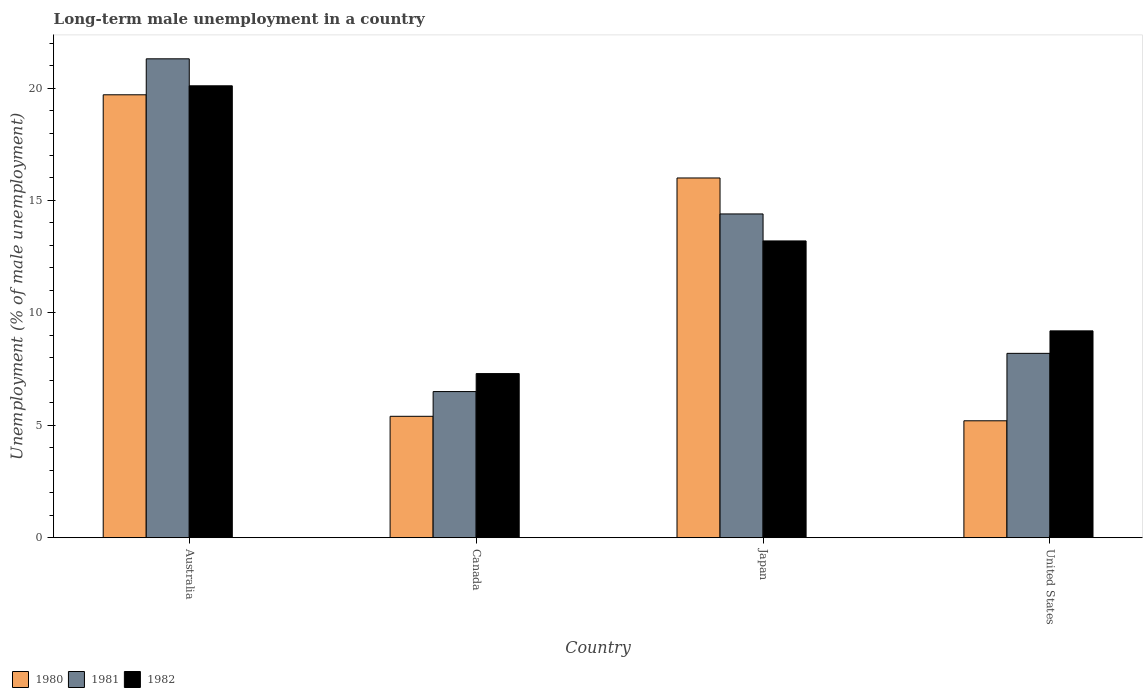How many different coloured bars are there?
Your response must be concise. 3. Are the number of bars per tick equal to the number of legend labels?
Provide a succinct answer. Yes. How many bars are there on the 4th tick from the right?
Your answer should be very brief. 3. What is the label of the 2nd group of bars from the left?
Give a very brief answer. Canada. In how many cases, is the number of bars for a given country not equal to the number of legend labels?
Your answer should be very brief. 0. What is the percentage of long-term unemployed male population in 1982 in United States?
Make the answer very short. 9.2. Across all countries, what is the maximum percentage of long-term unemployed male population in 1980?
Your answer should be very brief. 19.7. Across all countries, what is the minimum percentage of long-term unemployed male population in 1982?
Ensure brevity in your answer.  7.3. What is the total percentage of long-term unemployed male population in 1982 in the graph?
Your answer should be compact. 49.8. What is the difference between the percentage of long-term unemployed male population in 1980 in Canada and that in Japan?
Your answer should be very brief. -10.6. What is the difference between the percentage of long-term unemployed male population in 1982 in United States and the percentage of long-term unemployed male population in 1981 in Japan?
Your answer should be compact. -5.2. What is the average percentage of long-term unemployed male population in 1980 per country?
Provide a short and direct response. 11.58. What is the difference between the percentage of long-term unemployed male population of/in 1981 and percentage of long-term unemployed male population of/in 1980 in Japan?
Offer a very short reply. -1.6. What is the ratio of the percentage of long-term unemployed male population in 1980 in Australia to that in Canada?
Ensure brevity in your answer.  3.65. Is the percentage of long-term unemployed male population in 1982 in Japan less than that in United States?
Offer a terse response. No. Is the difference between the percentage of long-term unemployed male population in 1981 in Australia and Canada greater than the difference between the percentage of long-term unemployed male population in 1980 in Australia and Canada?
Offer a terse response. Yes. What is the difference between the highest and the second highest percentage of long-term unemployed male population in 1982?
Your response must be concise. -10.9. What is the difference between the highest and the lowest percentage of long-term unemployed male population in 1980?
Ensure brevity in your answer.  14.5. In how many countries, is the percentage of long-term unemployed male population in 1980 greater than the average percentage of long-term unemployed male population in 1980 taken over all countries?
Make the answer very short. 2. How many bars are there?
Provide a succinct answer. 12. Are all the bars in the graph horizontal?
Your answer should be very brief. No. Are the values on the major ticks of Y-axis written in scientific E-notation?
Offer a terse response. No. Does the graph contain any zero values?
Your answer should be very brief. No. Where does the legend appear in the graph?
Offer a terse response. Bottom left. What is the title of the graph?
Make the answer very short. Long-term male unemployment in a country. What is the label or title of the X-axis?
Provide a succinct answer. Country. What is the label or title of the Y-axis?
Keep it short and to the point. Unemployment (% of male unemployment). What is the Unemployment (% of male unemployment) of 1980 in Australia?
Keep it short and to the point. 19.7. What is the Unemployment (% of male unemployment) in 1981 in Australia?
Your answer should be very brief. 21.3. What is the Unemployment (% of male unemployment) in 1982 in Australia?
Provide a succinct answer. 20.1. What is the Unemployment (% of male unemployment) of 1980 in Canada?
Ensure brevity in your answer.  5.4. What is the Unemployment (% of male unemployment) in 1981 in Canada?
Provide a succinct answer. 6.5. What is the Unemployment (% of male unemployment) of 1982 in Canada?
Your answer should be very brief. 7.3. What is the Unemployment (% of male unemployment) in 1980 in Japan?
Give a very brief answer. 16. What is the Unemployment (% of male unemployment) in 1981 in Japan?
Provide a succinct answer. 14.4. What is the Unemployment (% of male unemployment) in 1982 in Japan?
Give a very brief answer. 13.2. What is the Unemployment (% of male unemployment) of 1980 in United States?
Make the answer very short. 5.2. What is the Unemployment (% of male unemployment) in 1981 in United States?
Make the answer very short. 8.2. What is the Unemployment (% of male unemployment) in 1982 in United States?
Offer a very short reply. 9.2. Across all countries, what is the maximum Unemployment (% of male unemployment) in 1980?
Ensure brevity in your answer.  19.7. Across all countries, what is the maximum Unemployment (% of male unemployment) in 1981?
Your answer should be compact. 21.3. Across all countries, what is the maximum Unemployment (% of male unemployment) in 1982?
Your response must be concise. 20.1. Across all countries, what is the minimum Unemployment (% of male unemployment) in 1980?
Your answer should be very brief. 5.2. Across all countries, what is the minimum Unemployment (% of male unemployment) of 1982?
Provide a succinct answer. 7.3. What is the total Unemployment (% of male unemployment) of 1980 in the graph?
Offer a terse response. 46.3. What is the total Unemployment (% of male unemployment) in 1981 in the graph?
Ensure brevity in your answer.  50.4. What is the total Unemployment (% of male unemployment) of 1982 in the graph?
Your answer should be compact. 49.8. What is the difference between the Unemployment (% of male unemployment) in 1980 in Australia and that in Canada?
Your response must be concise. 14.3. What is the difference between the Unemployment (% of male unemployment) of 1982 in Australia and that in Canada?
Make the answer very short. 12.8. What is the difference between the Unemployment (% of male unemployment) in 1980 in Australia and that in Japan?
Offer a very short reply. 3.7. What is the difference between the Unemployment (% of male unemployment) in 1980 in Canada and that in Japan?
Make the answer very short. -10.6. What is the difference between the Unemployment (% of male unemployment) of 1981 in Canada and that in Japan?
Provide a succinct answer. -7.9. What is the difference between the Unemployment (% of male unemployment) of 1980 in Canada and that in United States?
Provide a succinct answer. 0.2. What is the difference between the Unemployment (% of male unemployment) in 1980 in Japan and that in United States?
Offer a terse response. 10.8. What is the difference between the Unemployment (% of male unemployment) in 1982 in Japan and that in United States?
Give a very brief answer. 4. What is the difference between the Unemployment (% of male unemployment) in 1980 in Australia and the Unemployment (% of male unemployment) in 1981 in Canada?
Give a very brief answer. 13.2. What is the difference between the Unemployment (% of male unemployment) in 1980 in Australia and the Unemployment (% of male unemployment) in 1981 in Japan?
Offer a very short reply. 5.3. What is the difference between the Unemployment (% of male unemployment) of 1980 in Australia and the Unemployment (% of male unemployment) of 1982 in United States?
Make the answer very short. 10.5. What is the difference between the Unemployment (% of male unemployment) in 1980 in Canada and the Unemployment (% of male unemployment) in 1981 in Japan?
Make the answer very short. -9. What is the difference between the Unemployment (% of male unemployment) in 1980 in Canada and the Unemployment (% of male unemployment) in 1981 in United States?
Provide a short and direct response. -2.8. What is the difference between the Unemployment (% of male unemployment) in 1981 in Japan and the Unemployment (% of male unemployment) in 1982 in United States?
Your answer should be very brief. 5.2. What is the average Unemployment (% of male unemployment) in 1980 per country?
Ensure brevity in your answer.  11.57. What is the average Unemployment (% of male unemployment) in 1981 per country?
Provide a short and direct response. 12.6. What is the average Unemployment (% of male unemployment) in 1982 per country?
Your answer should be very brief. 12.45. What is the difference between the Unemployment (% of male unemployment) of 1980 and Unemployment (% of male unemployment) of 1981 in Australia?
Offer a terse response. -1.6. What is the difference between the Unemployment (% of male unemployment) of 1981 and Unemployment (% of male unemployment) of 1982 in Australia?
Offer a very short reply. 1.2. What is the difference between the Unemployment (% of male unemployment) in 1980 and Unemployment (% of male unemployment) in 1982 in Canada?
Keep it short and to the point. -1.9. What is the difference between the Unemployment (% of male unemployment) in 1981 and Unemployment (% of male unemployment) in 1982 in Canada?
Ensure brevity in your answer.  -0.8. What is the difference between the Unemployment (% of male unemployment) in 1980 and Unemployment (% of male unemployment) in 1982 in Japan?
Offer a very short reply. 2.8. What is the difference between the Unemployment (% of male unemployment) of 1980 and Unemployment (% of male unemployment) of 1981 in United States?
Your answer should be compact. -3. What is the difference between the Unemployment (% of male unemployment) in 1980 and Unemployment (% of male unemployment) in 1982 in United States?
Ensure brevity in your answer.  -4. What is the ratio of the Unemployment (% of male unemployment) in 1980 in Australia to that in Canada?
Provide a short and direct response. 3.65. What is the ratio of the Unemployment (% of male unemployment) in 1981 in Australia to that in Canada?
Provide a succinct answer. 3.28. What is the ratio of the Unemployment (% of male unemployment) in 1982 in Australia to that in Canada?
Offer a very short reply. 2.75. What is the ratio of the Unemployment (% of male unemployment) of 1980 in Australia to that in Japan?
Ensure brevity in your answer.  1.23. What is the ratio of the Unemployment (% of male unemployment) of 1981 in Australia to that in Japan?
Keep it short and to the point. 1.48. What is the ratio of the Unemployment (% of male unemployment) in 1982 in Australia to that in Japan?
Your answer should be compact. 1.52. What is the ratio of the Unemployment (% of male unemployment) of 1980 in Australia to that in United States?
Your answer should be very brief. 3.79. What is the ratio of the Unemployment (% of male unemployment) of 1981 in Australia to that in United States?
Your answer should be compact. 2.6. What is the ratio of the Unemployment (% of male unemployment) of 1982 in Australia to that in United States?
Offer a very short reply. 2.18. What is the ratio of the Unemployment (% of male unemployment) of 1980 in Canada to that in Japan?
Ensure brevity in your answer.  0.34. What is the ratio of the Unemployment (% of male unemployment) of 1981 in Canada to that in Japan?
Offer a terse response. 0.45. What is the ratio of the Unemployment (% of male unemployment) of 1982 in Canada to that in Japan?
Provide a short and direct response. 0.55. What is the ratio of the Unemployment (% of male unemployment) of 1981 in Canada to that in United States?
Make the answer very short. 0.79. What is the ratio of the Unemployment (% of male unemployment) of 1982 in Canada to that in United States?
Provide a short and direct response. 0.79. What is the ratio of the Unemployment (% of male unemployment) of 1980 in Japan to that in United States?
Offer a very short reply. 3.08. What is the ratio of the Unemployment (% of male unemployment) in 1981 in Japan to that in United States?
Your response must be concise. 1.76. What is the ratio of the Unemployment (% of male unemployment) in 1982 in Japan to that in United States?
Make the answer very short. 1.43. What is the difference between the highest and the second highest Unemployment (% of male unemployment) of 1980?
Your response must be concise. 3.7. What is the difference between the highest and the second highest Unemployment (% of male unemployment) of 1981?
Keep it short and to the point. 6.9. What is the difference between the highest and the second highest Unemployment (% of male unemployment) in 1982?
Give a very brief answer. 6.9. What is the difference between the highest and the lowest Unemployment (% of male unemployment) in 1980?
Keep it short and to the point. 14.5. What is the difference between the highest and the lowest Unemployment (% of male unemployment) of 1981?
Offer a very short reply. 14.8. 